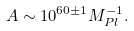Convert formula to latex. <formula><loc_0><loc_0><loc_500><loc_500>A \sim 1 0 ^ { 6 0 \pm 1 } M _ { P l } ^ { - 1 } .</formula> 